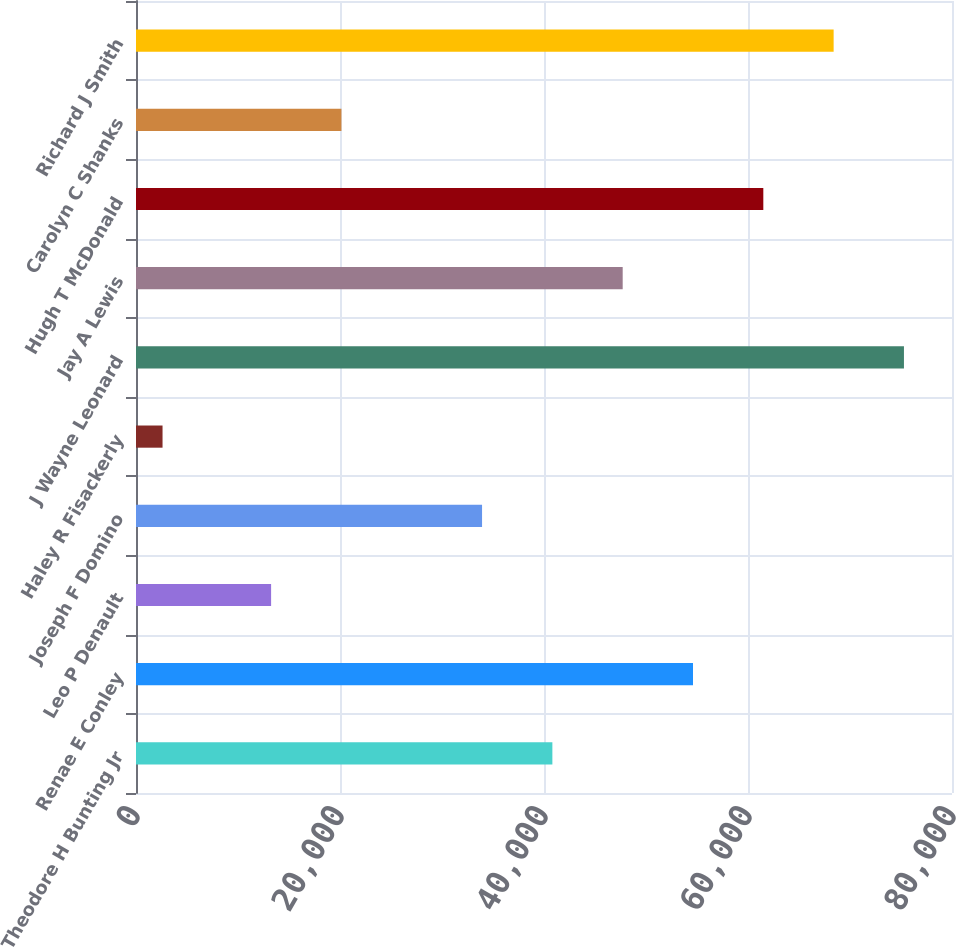Convert chart to OTSL. <chart><loc_0><loc_0><loc_500><loc_500><bar_chart><fcel>Theodore H Bunting Jr<fcel>Renae E Conley<fcel>Leo P Denault<fcel>Joseph F Domino<fcel>Haley R Fisackerly<fcel>J Wayne Leonard<fcel>Jay A Lewis<fcel>Hugh T McDonald<fcel>Carolyn C Shanks<fcel>Richard J Smith<nl><fcel>40820.8<fcel>54608.2<fcel>13246<fcel>33927.1<fcel>2602<fcel>75289.3<fcel>47714.5<fcel>61501.9<fcel>20139.7<fcel>68395.6<nl></chart> 